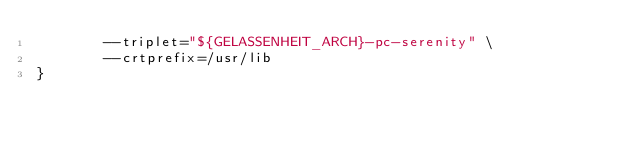<code> <loc_0><loc_0><loc_500><loc_500><_Bash_>        --triplet="${GELASSENHEIT_ARCH}-pc-serenity" \
        --crtprefix=/usr/lib
}
</code> 